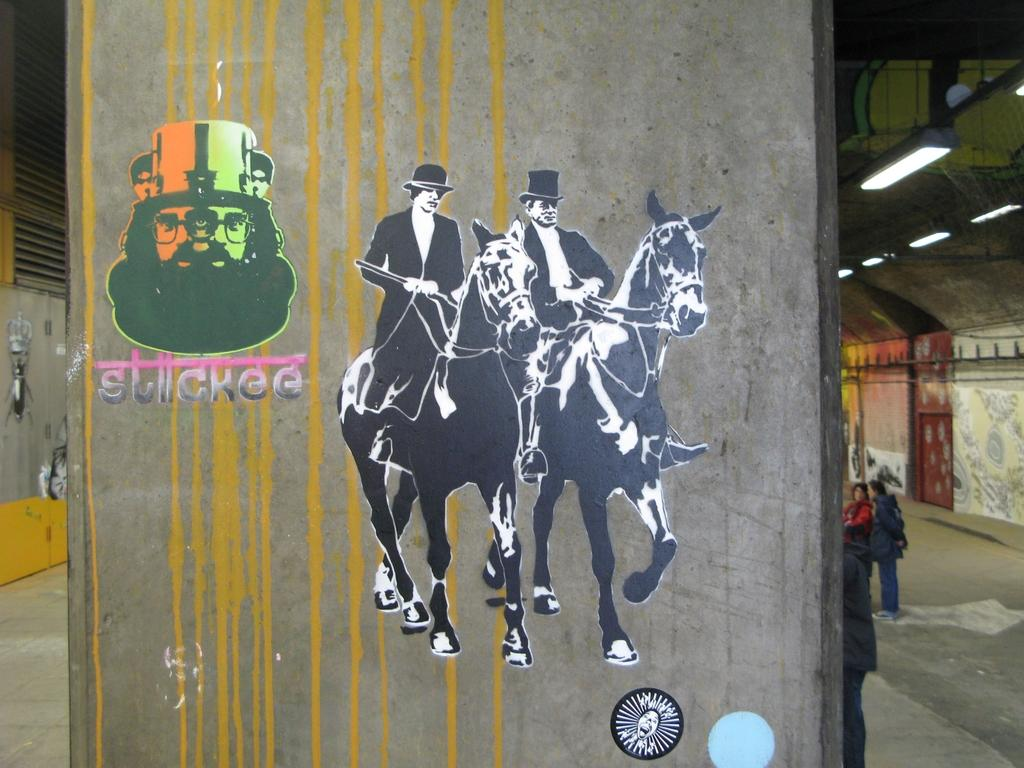What is on the wall in the image? There is a painting on the wall in the image. What is the subject of the painting? The painting depicts two men. What are the men in the painting doing? The men in the painting are riding horses. How many goldfish can be seen swimming in the painting? There are no goldfish present in the painting; it features two men riding horses. What type of verse is recited by the men in the painting? There is no indication in the painting that the men are reciting any verse. 